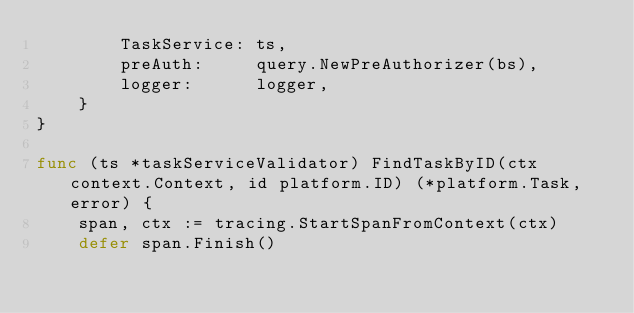Convert code to text. <code><loc_0><loc_0><loc_500><loc_500><_Go_>		TaskService: ts,
		preAuth:     query.NewPreAuthorizer(bs),
		logger:      logger,
	}
}

func (ts *taskServiceValidator) FindTaskByID(ctx context.Context, id platform.ID) (*platform.Task, error) {
	span, ctx := tracing.StartSpanFromContext(ctx)
	defer span.Finish()
</code> 